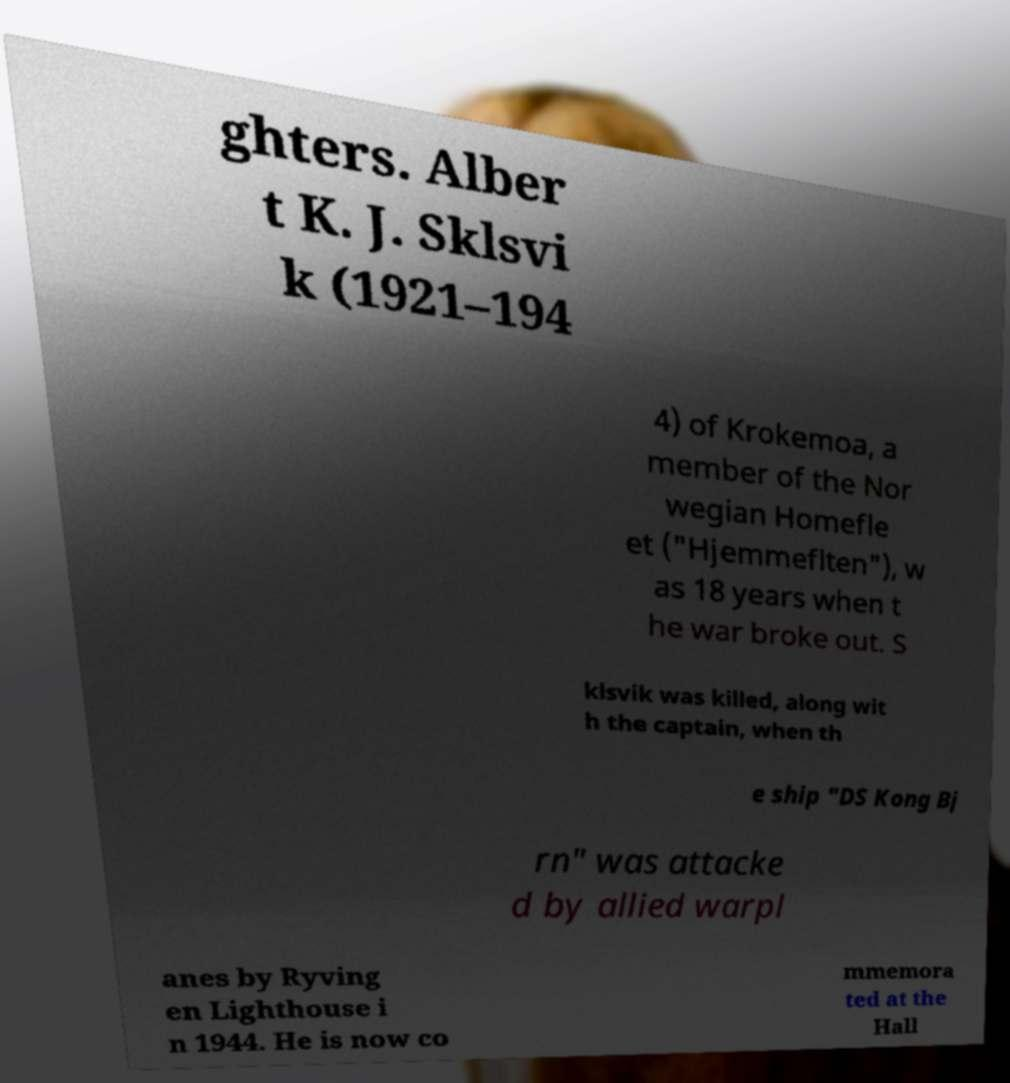For documentation purposes, I need the text within this image transcribed. Could you provide that? ghters. Alber t K. J. Sklsvi k (1921–194 4) of Krokemoa, a member of the Nor wegian Homefle et ("Hjemmeflten"), w as 18 years when t he war broke out. S klsvik was killed, along wit h the captain, when th e ship "DS Kong Bj rn" was attacke d by allied warpl anes by Ryving en Lighthouse i n 1944. He is now co mmemora ted at the Hall 